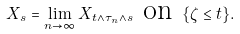Convert formula to latex. <formula><loc_0><loc_0><loc_500><loc_500>X _ { s } = \lim _ { n \to \infty } X _ { t \wedge \tau _ { n } \wedge s } \text { on } \{ \zeta \leq t \} .</formula> 